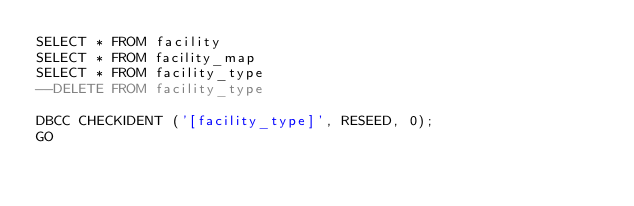<code> <loc_0><loc_0><loc_500><loc_500><_SQL_>SELECT * FROM facility
SELECT * FROM facility_map
SELECT * FROM facility_type
--DELETE FROM facility_type

DBCC CHECKIDENT ('[facility_type]', RESEED, 0);
GO</code> 